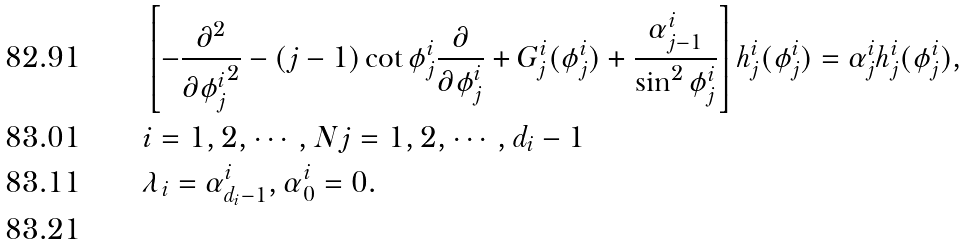Convert formula to latex. <formula><loc_0><loc_0><loc_500><loc_500>& \left [ - \frac { \partial ^ { 2 } } { \partial { \phi ^ { i } _ { j } } ^ { 2 } } - ( j - 1 ) \cot \phi ^ { i } _ { j } \frac { \partial } { \partial \phi ^ { i } _ { j } } + G ^ { i } _ { j } ( \phi ^ { i } _ { j } ) + \frac { \alpha ^ { i } _ { j - 1 } } { \sin ^ { 2 } \phi ^ { i } _ { j } } \right ] h ^ { i } _ { j } ( \phi ^ { i } _ { j } ) = \alpha ^ { i } _ { j } h ^ { i } _ { j } ( \phi ^ { i } _ { j } ) , \\ & i = 1 , 2 , \cdots , N j = 1 , 2 , \cdots , d _ { i } - 1 \\ & \lambda _ { i } = \alpha ^ { i } _ { d _ { i } - 1 } , \alpha ^ { i } _ { 0 } = 0 . \\</formula> 